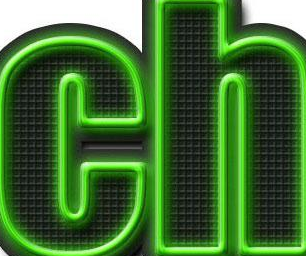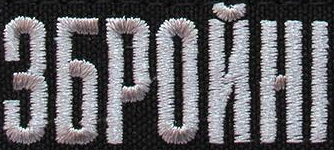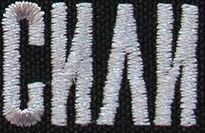Read the text from these images in sequence, separated by a semicolon. ch; ЗБPOЙHI; CИΛИ 